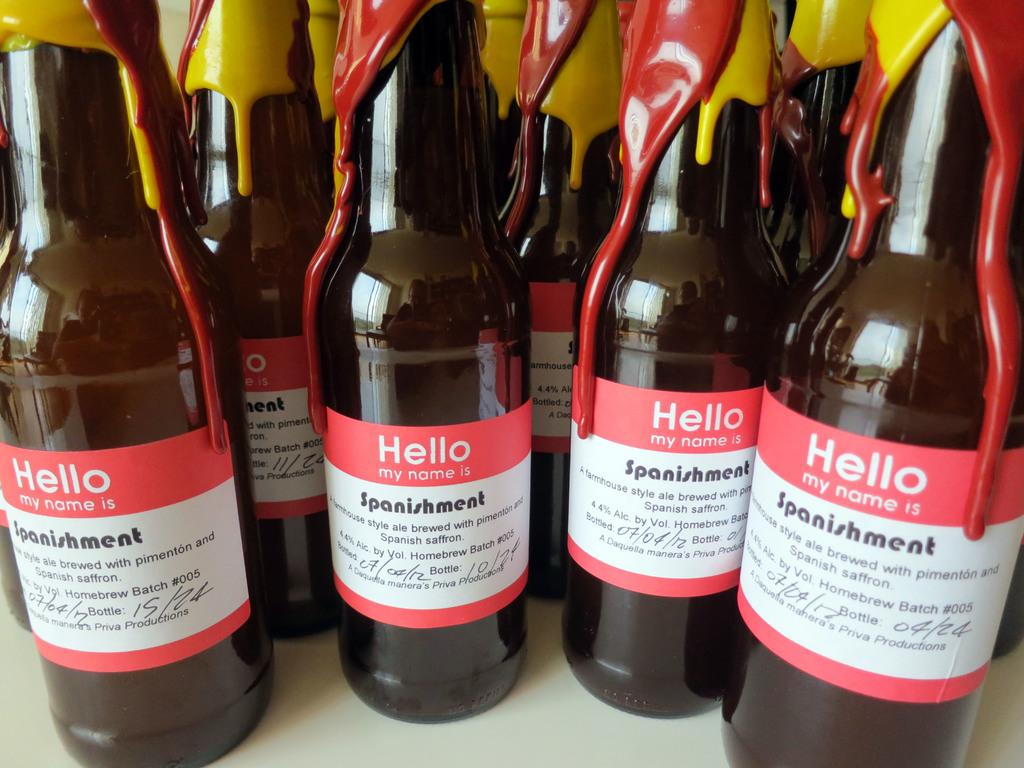Provide a one-sentence caption for the provided image. Four bottles of beer which read 'hello my name is'. 